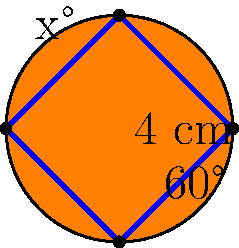In the simplified Firefox logo above, the central shape is formed by four curved edges. The bottom angle is 60°, and the height of the shape is 4 cm. If the shape is symmetrical, what is the value of x° (the top angle)? Let's approach this step-by-step:

1) First, we need to recognize that the shape is symmetrical. This means that the left and right halves are mirror images of each other.

2) In a symmetrical shape like this, the top and bottom angles are supplementary, meaning they add up to 180°.

3) We can express this relationship mathematically:
   $$x° + 60° = 180°$$

4) To solve for x, we subtract 60° from both sides:
   $$x° = 180° - 60°$$

5) Simplifying:
   $$x° = 120°$$

Therefore, the top angle (x°) in the Firefox logo is 120°.
Answer: 120° 